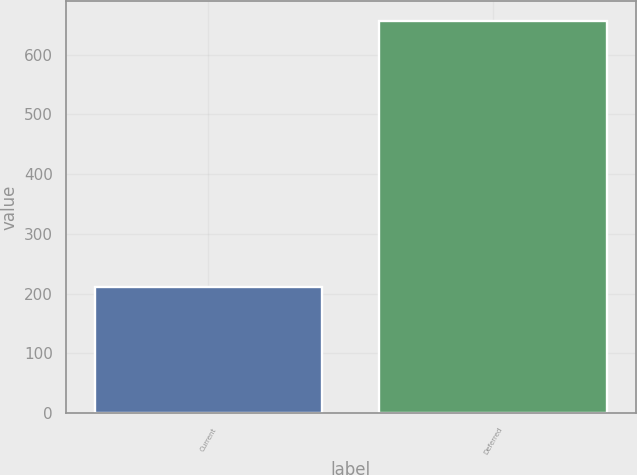Convert chart. <chart><loc_0><loc_0><loc_500><loc_500><bar_chart><fcel>Current<fcel>Deferred<nl><fcel>211<fcel>657<nl></chart> 